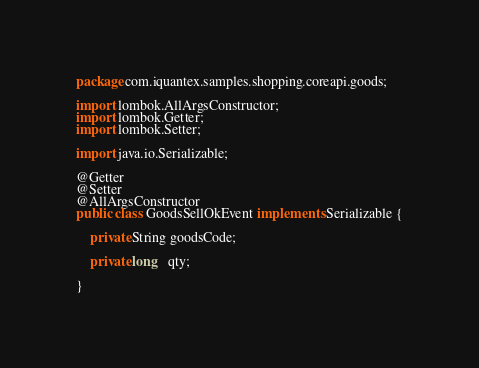Convert code to text. <code><loc_0><loc_0><loc_500><loc_500><_Java_>package com.iquantex.samples.shopping.coreapi.goods;

import lombok.AllArgsConstructor;
import lombok.Getter;
import lombok.Setter;

import java.io.Serializable;

@Getter
@Setter
@AllArgsConstructor
public class GoodsSellOkEvent implements Serializable {

    private String goodsCode;

    private long   qty;

}
</code> 